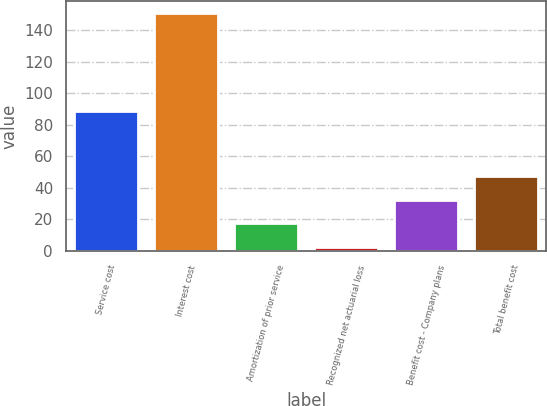Convert chart. <chart><loc_0><loc_0><loc_500><loc_500><bar_chart><fcel>Service cost<fcel>Interest cost<fcel>Amortization of prior service<fcel>Recognized net actuarial loss<fcel>Benefit cost - Company plans<fcel>Total benefit cost<nl><fcel>89<fcel>151.1<fcel>17.54<fcel>2.7<fcel>32.38<fcel>47.22<nl></chart> 